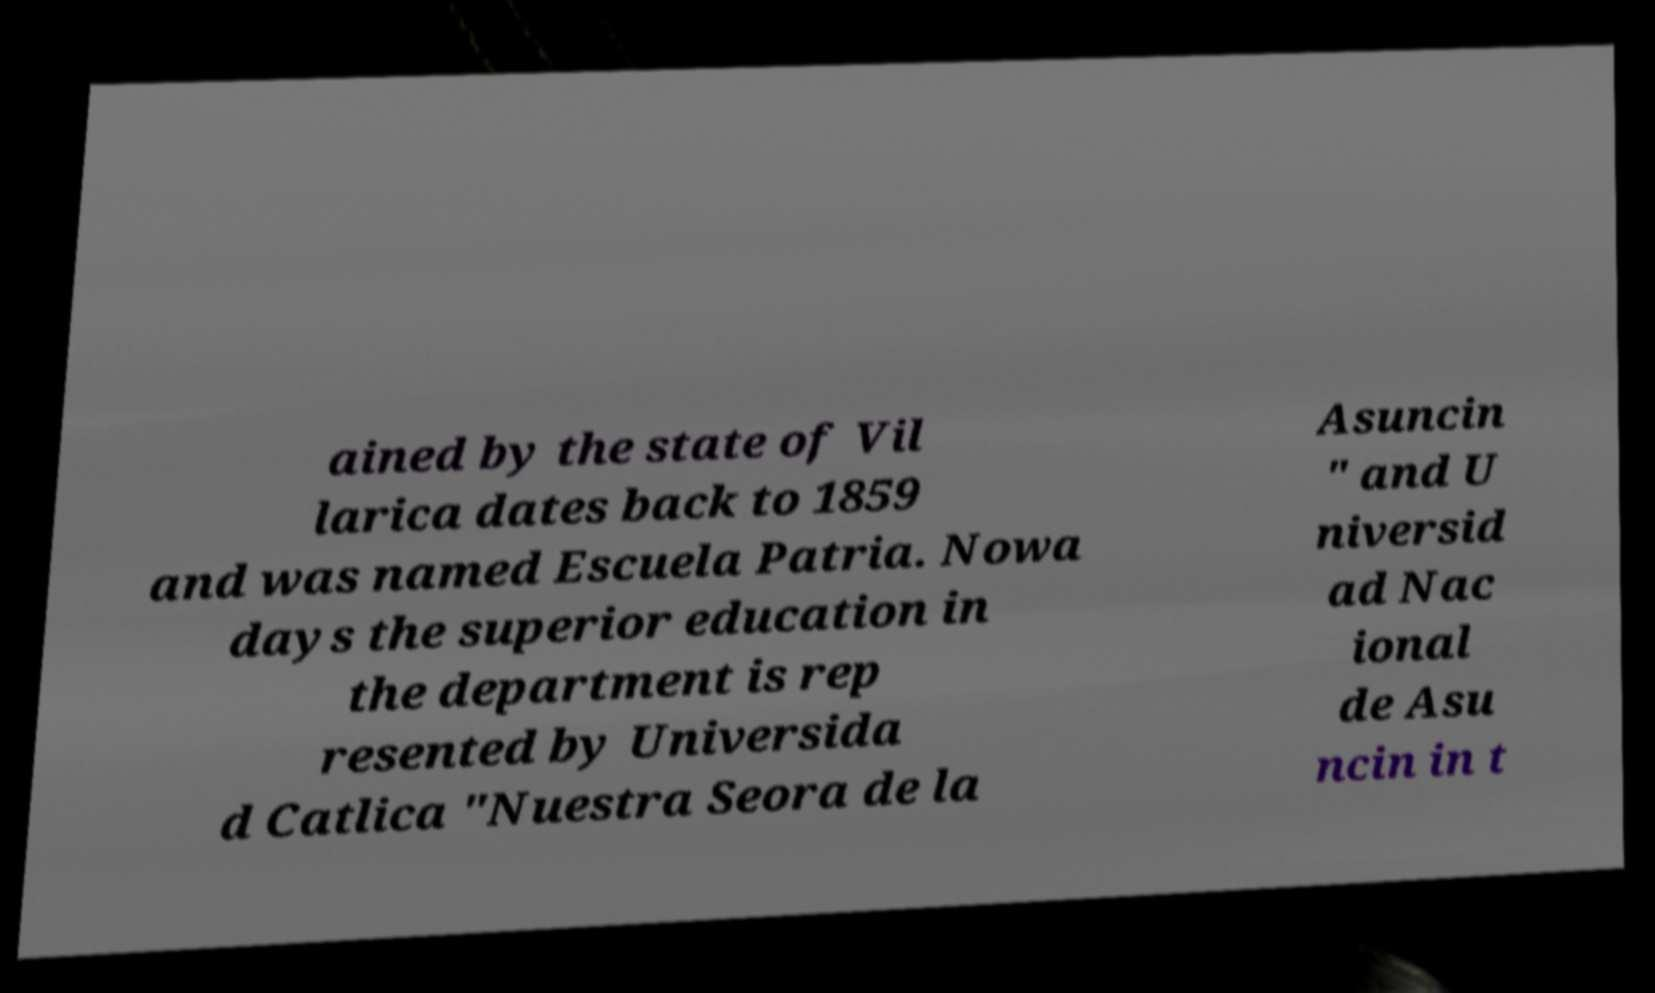Can you accurately transcribe the text from the provided image for me? ained by the state of Vil larica dates back to 1859 and was named Escuela Patria. Nowa days the superior education in the department is rep resented by Universida d Catlica "Nuestra Seora de la Asuncin " and U niversid ad Nac ional de Asu ncin in t 